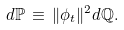<formula> <loc_0><loc_0><loc_500><loc_500>d { \mathbb { P } } \, \equiv \, \| \phi _ { t } \| ^ { 2 } d { \mathbb { Q } } .</formula> 